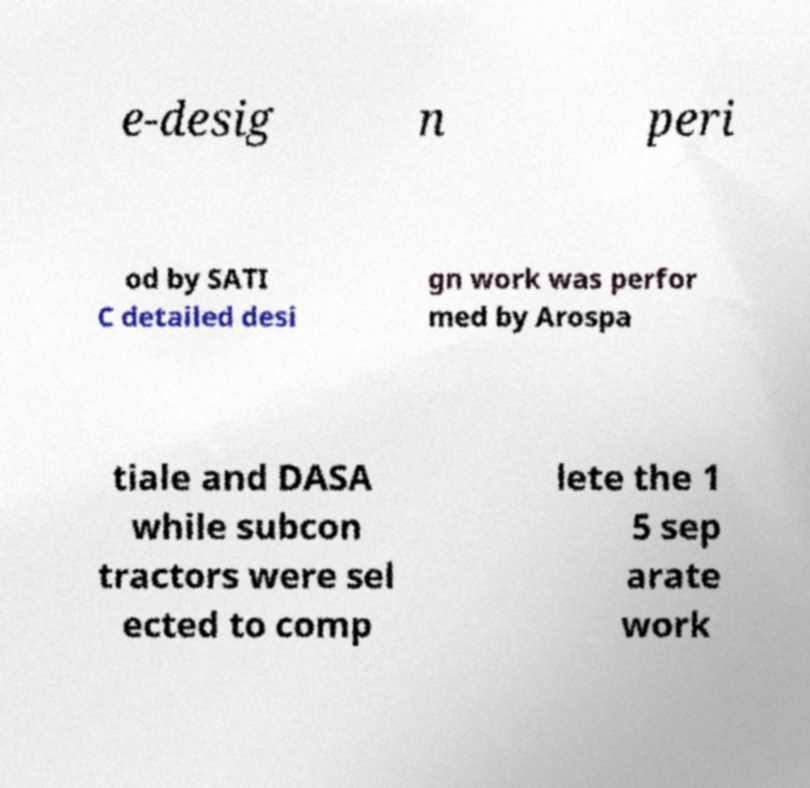What messages or text are displayed in this image? I need them in a readable, typed format. e-desig n peri od by SATI C detailed desi gn work was perfor med by Arospa tiale and DASA while subcon tractors were sel ected to comp lete the 1 5 sep arate work 